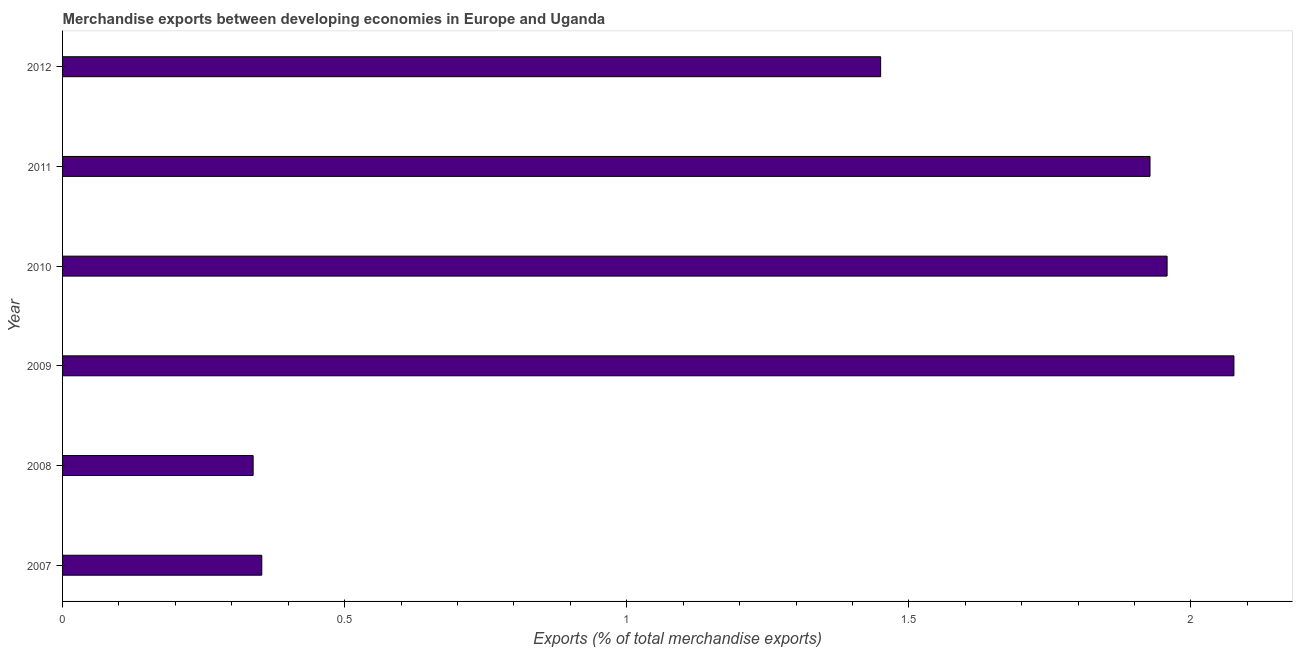Does the graph contain grids?
Your answer should be compact. No. What is the title of the graph?
Make the answer very short. Merchandise exports between developing economies in Europe and Uganda. What is the label or title of the X-axis?
Your answer should be very brief. Exports (% of total merchandise exports). What is the merchandise exports in 2009?
Ensure brevity in your answer.  2.08. Across all years, what is the maximum merchandise exports?
Offer a very short reply. 2.08. Across all years, what is the minimum merchandise exports?
Your answer should be very brief. 0.34. What is the sum of the merchandise exports?
Make the answer very short. 8.1. What is the difference between the merchandise exports in 2008 and 2009?
Your response must be concise. -1.74. What is the average merchandise exports per year?
Your response must be concise. 1.35. What is the median merchandise exports?
Offer a very short reply. 1.69. In how many years, is the merchandise exports greater than 0.1 %?
Give a very brief answer. 6. Do a majority of the years between 2007 and 2010 (inclusive) have merchandise exports greater than 0.8 %?
Give a very brief answer. No. What is the ratio of the merchandise exports in 2009 to that in 2010?
Ensure brevity in your answer.  1.06. What is the difference between the highest and the second highest merchandise exports?
Your answer should be very brief. 0.12. Is the sum of the merchandise exports in 2007 and 2009 greater than the maximum merchandise exports across all years?
Your response must be concise. Yes. What is the difference between the highest and the lowest merchandise exports?
Give a very brief answer. 1.74. In how many years, is the merchandise exports greater than the average merchandise exports taken over all years?
Offer a very short reply. 4. How many years are there in the graph?
Offer a terse response. 6. What is the Exports (% of total merchandise exports) in 2007?
Your response must be concise. 0.35. What is the Exports (% of total merchandise exports) in 2008?
Keep it short and to the point. 0.34. What is the Exports (% of total merchandise exports) in 2009?
Give a very brief answer. 2.08. What is the Exports (% of total merchandise exports) of 2010?
Provide a short and direct response. 1.96. What is the Exports (% of total merchandise exports) in 2011?
Provide a succinct answer. 1.93. What is the Exports (% of total merchandise exports) of 2012?
Your response must be concise. 1.45. What is the difference between the Exports (% of total merchandise exports) in 2007 and 2008?
Provide a succinct answer. 0.02. What is the difference between the Exports (% of total merchandise exports) in 2007 and 2009?
Your response must be concise. -1.72. What is the difference between the Exports (% of total merchandise exports) in 2007 and 2010?
Ensure brevity in your answer.  -1.6. What is the difference between the Exports (% of total merchandise exports) in 2007 and 2011?
Offer a terse response. -1.57. What is the difference between the Exports (% of total merchandise exports) in 2007 and 2012?
Your answer should be very brief. -1.1. What is the difference between the Exports (% of total merchandise exports) in 2008 and 2009?
Keep it short and to the point. -1.74. What is the difference between the Exports (% of total merchandise exports) in 2008 and 2010?
Your answer should be very brief. -1.62. What is the difference between the Exports (% of total merchandise exports) in 2008 and 2011?
Make the answer very short. -1.59. What is the difference between the Exports (% of total merchandise exports) in 2008 and 2012?
Keep it short and to the point. -1.11. What is the difference between the Exports (% of total merchandise exports) in 2009 and 2010?
Give a very brief answer. 0.12. What is the difference between the Exports (% of total merchandise exports) in 2009 and 2011?
Provide a succinct answer. 0.15. What is the difference between the Exports (% of total merchandise exports) in 2009 and 2012?
Give a very brief answer. 0.63. What is the difference between the Exports (% of total merchandise exports) in 2010 and 2011?
Your answer should be compact. 0.03. What is the difference between the Exports (% of total merchandise exports) in 2010 and 2012?
Your answer should be compact. 0.51. What is the difference between the Exports (% of total merchandise exports) in 2011 and 2012?
Your response must be concise. 0.48. What is the ratio of the Exports (% of total merchandise exports) in 2007 to that in 2008?
Your answer should be very brief. 1.04. What is the ratio of the Exports (% of total merchandise exports) in 2007 to that in 2009?
Keep it short and to the point. 0.17. What is the ratio of the Exports (% of total merchandise exports) in 2007 to that in 2010?
Offer a very short reply. 0.18. What is the ratio of the Exports (% of total merchandise exports) in 2007 to that in 2011?
Provide a succinct answer. 0.18. What is the ratio of the Exports (% of total merchandise exports) in 2007 to that in 2012?
Offer a very short reply. 0.24. What is the ratio of the Exports (% of total merchandise exports) in 2008 to that in 2009?
Ensure brevity in your answer.  0.16. What is the ratio of the Exports (% of total merchandise exports) in 2008 to that in 2010?
Make the answer very short. 0.17. What is the ratio of the Exports (% of total merchandise exports) in 2008 to that in 2011?
Keep it short and to the point. 0.17. What is the ratio of the Exports (% of total merchandise exports) in 2008 to that in 2012?
Give a very brief answer. 0.23. What is the ratio of the Exports (% of total merchandise exports) in 2009 to that in 2010?
Offer a terse response. 1.06. What is the ratio of the Exports (% of total merchandise exports) in 2009 to that in 2011?
Provide a short and direct response. 1.08. What is the ratio of the Exports (% of total merchandise exports) in 2009 to that in 2012?
Offer a very short reply. 1.43. What is the ratio of the Exports (% of total merchandise exports) in 2010 to that in 2012?
Give a very brief answer. 1.35. What is the ratio of the Exports (% of total merchandise exports) in 2011 to that in 2012?
Provide a succinct answer. 1.33. 